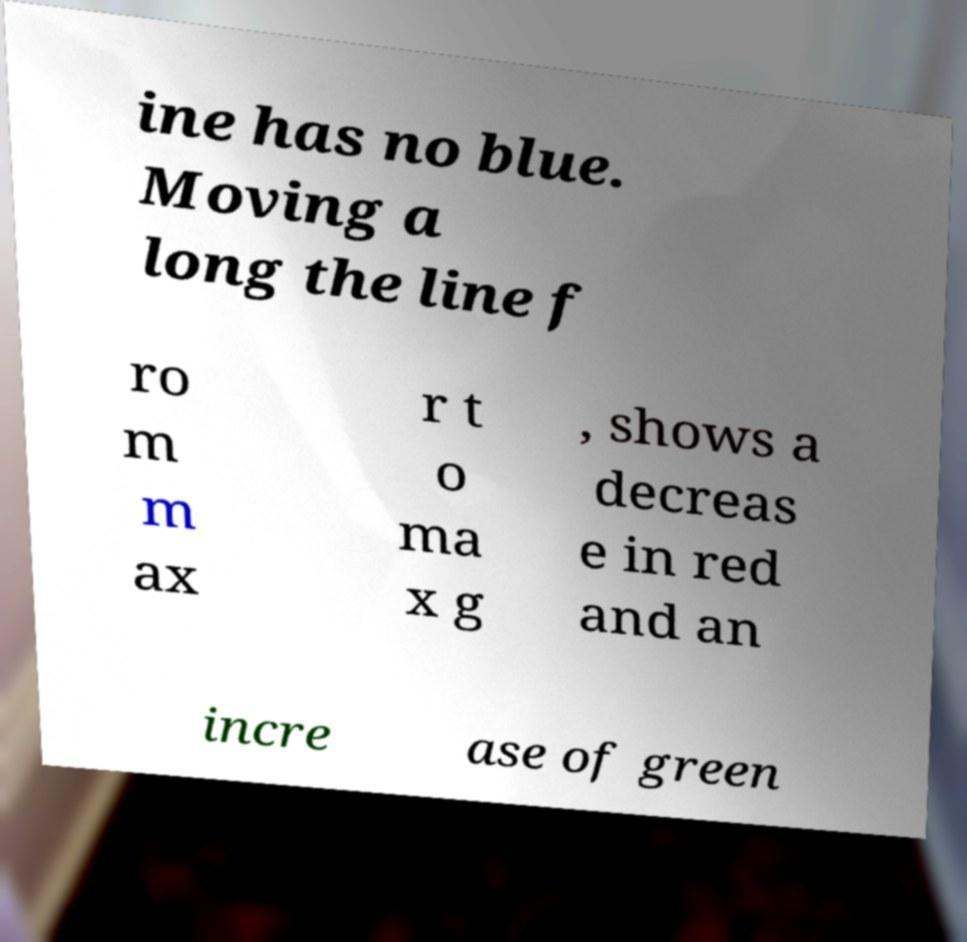There's text embedded in this image that I need extracted. Can you transcribe it verbatim? ine has no blue. Moving a long the line f ro m m ax r t o ma x g , shows a decreas e in red and an incre ase of green 